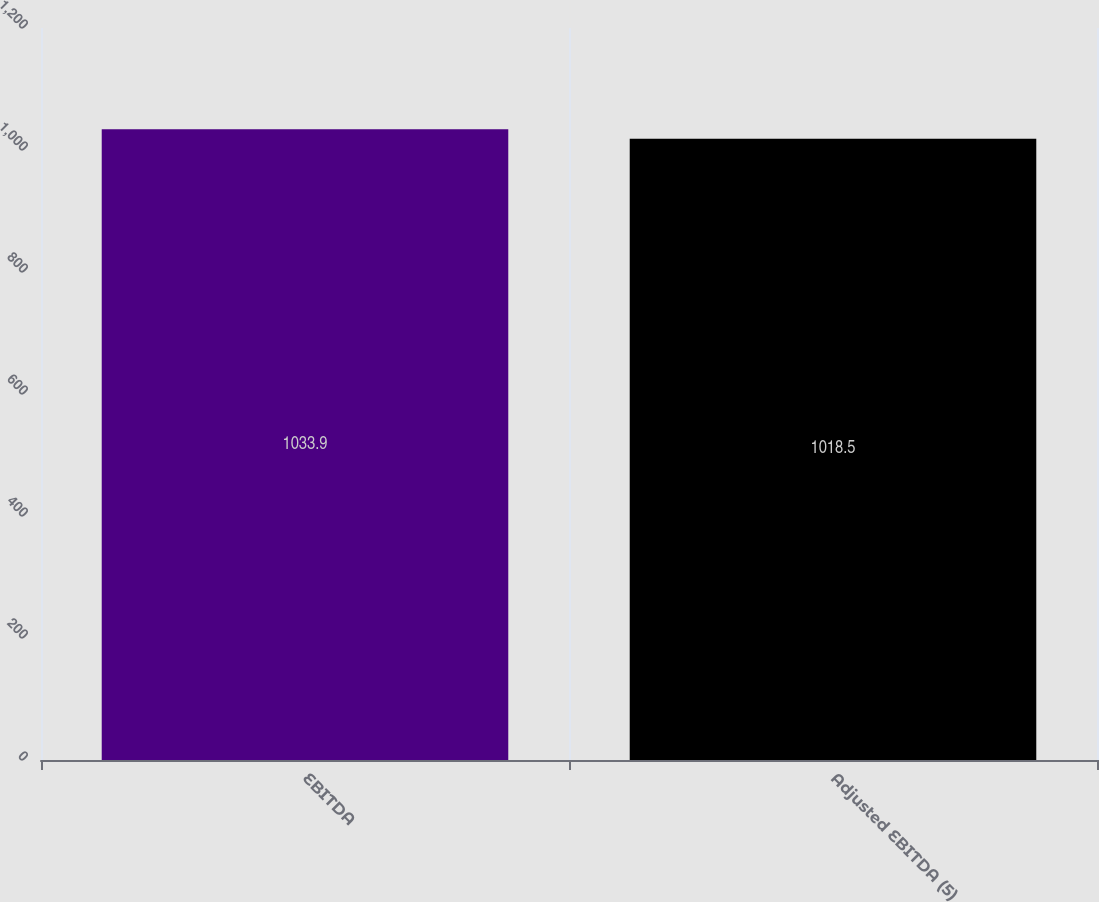<chart> <loc_0><loc_0><loc_500><loc_500><bar_chart><fcel>EBITDA<fcel>Adjusted EBITDA (5)<nl><fcel>1033.9<fcel>1018.5<nl></chart> 